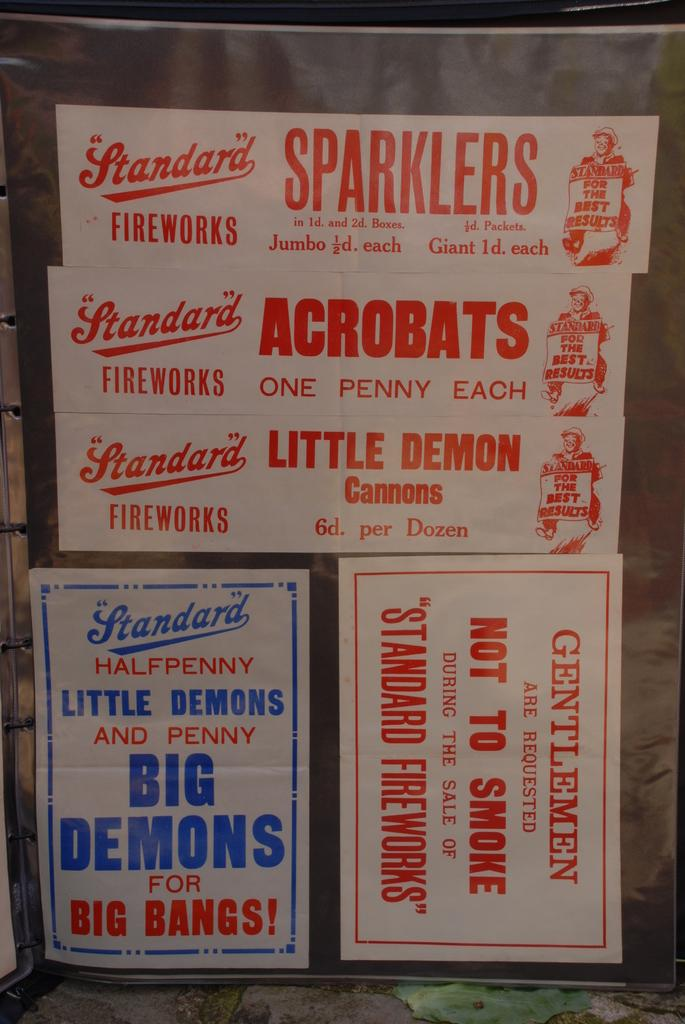<image>
Summarize the visual content of the image. Stickers advertise Standard fireworks and sparklers in red letters. 